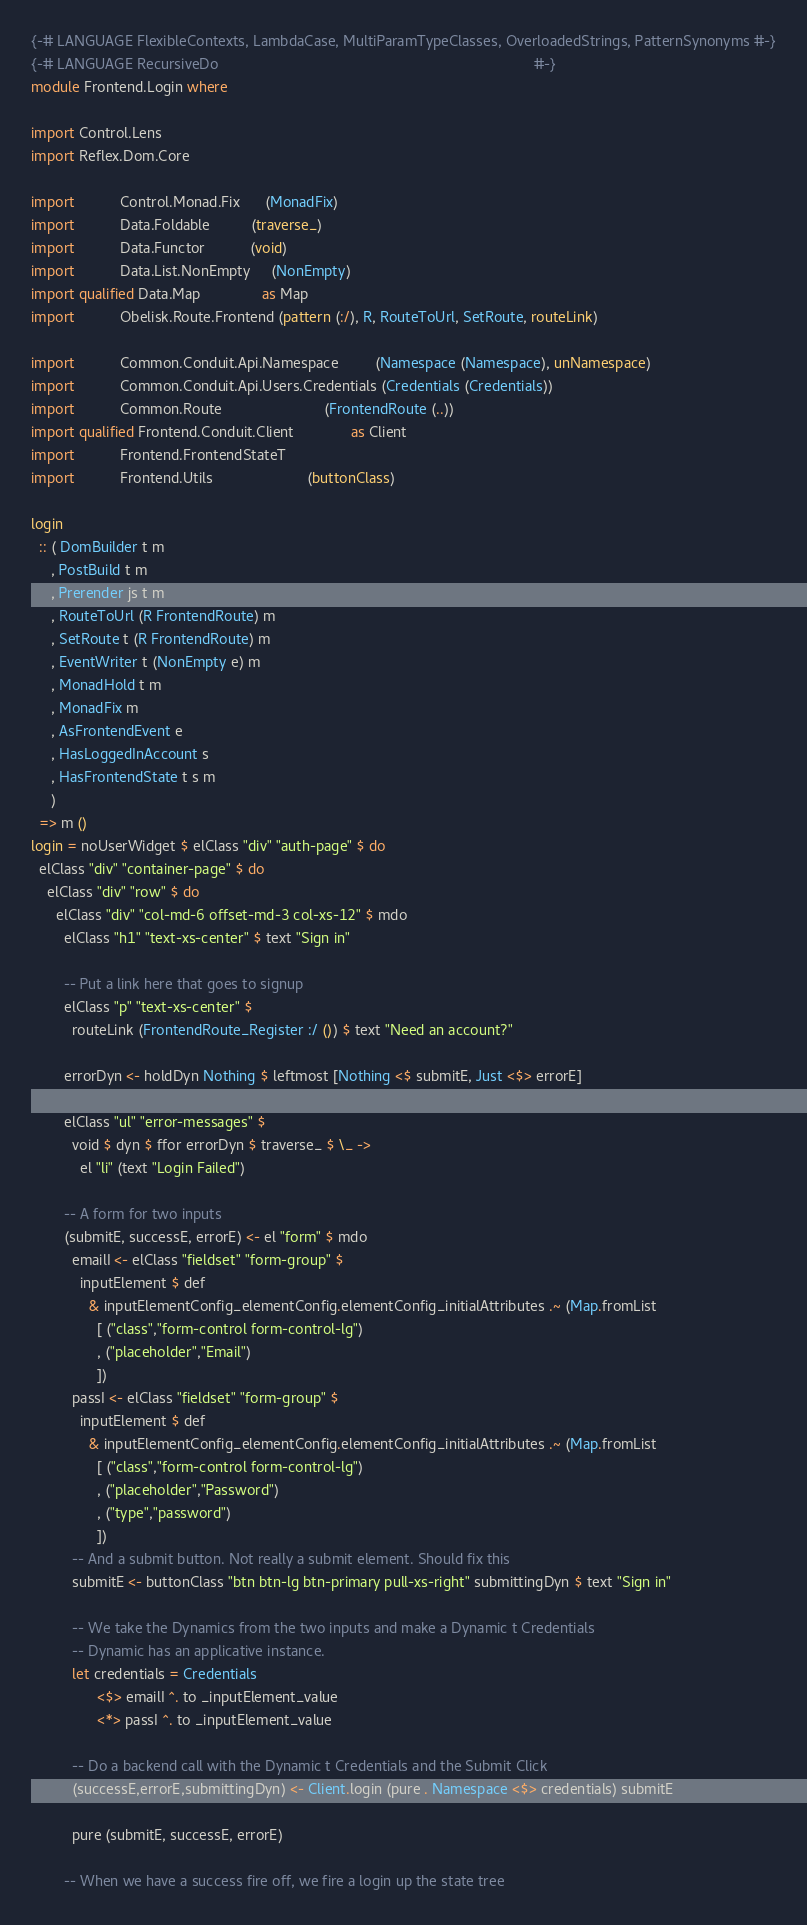<code> <loc_0><loc_0><loc_500><loc_500><_Haskell_>{-# LANGUAGE FlexibleContexts, LambdaCase, MultiParamTypeClasses, OverloadedStrings, PatternSynonyms #-}
{-# LANGUAGE RecursiveDo                                                                             #-}
module Frontend.Login where

import Control.Lens
import Reflex.Dom.Core

import           Control.Monad.Fix      (MonadFix)
import           Data.Foldable          (traverse_)
import           Data.Functor           (void)
import           Data.List.NonEmpty     (NonEmpty)
import qualified Data.Map               as Map
import           Obelisk.Route.Frontend (pattern (:/), R, RouteToUrl, SetRoute, routeLink)

import           Common.Conduit.Api.Namespace         (Namespace (Namespace), unNamespace)
import           Common.Conduit.Api.Users.Credentials (Credentials (Credentials))
import           Common.Route                         (FrontendRoute (..))
import qualified Frontend.Conduit.Client              as Client
import           Frontend.FrontendStateT
import           Frontend.Utils                       (buttonClass)

login
  :: ( DomBuilder t m
     , PostBuild t m
     , Prerender js t m
     , RouteToUrl (R FrontendRoute) m
     , SetRoute t (R FrontendRoute) m
     , EventWriter t (NonEmpty e) m
     , MonadHold t m
     , MonadFix m
     , AsFrontendEvent e
     , HasLoggedInAccount s
     , HasFrontendState t s m
     )
  => m ()
login = noUserWidget $ elClass "div" "auth-page" $ do
  elClass "div" "container-page" $ do
    elClass "div" "row" $ do
      elClass "div" "col-md-6 offset-md-3 col-xs-12" $ mdo
        elClass "h1" "text-xs-center" $ text "Sign in"

        -- Put a link here that goes to signup
        elClass "p" "text-xs-center" $
          routeLink (FrontendRoute_Register :/ ()) $ text "Need an account?"

        errorDyn <- holdDyn Nothing $ leftmost [Nothing <$ submitE, Just <$> errorE]

        elClass "ul" "error-messages" $
          void $ dyn $ ffor errorDyn $ traverse_ $ \_ ->
            el "li" (text "Login Failed")

        -- A form for two inputs
        (submitE, successE, errorE) <- el "form" $ mdo
          emailI <- elClass "fieldset" "form-group" $
            inputElement $ def
              & inputElementConfig_elementConfig.elementConfig_initialAttributes .~ (Map.fromList
                [ ("class","form-control form-control-lg")
                , ("placeholder","Email")
                ])
          passI <- elClass "fieldset" "form-group" $
            inputElement $ def
              & inputElementConfig_elementConfig.elementConfig_initialAttributes .~ (Map.fromList
                [ ("class","form-control form-control-lg")
                , ("placeholder","Password")
                , ("type","password")
                ])
          -- And a submit button. Not really a submit element. Should fix this
          submitE <- buttonClass "btn btn-lg btn-primary pull-xs-right" submittingDyn $ text "Sign in"

          -- We take the Dynamics from the two inputs and make a Dynamic t Credentials
          -- Dynamic has an applicative instance.
          let credentials = Credentials
                <$> emailI ^. to _inputElement_value
                <*> passI ^. to _inputElement_value

          -- Do a backend call with the Dynamic t Credentials and the Submit Click
          (successE,errorE,submittingDyn) <- Client.login (pure . Namespace <$> credentials) submitE

          pure (submitE, successE, errorE)

        -- When we have a success fire off, we fire a login up the state tree</code> 